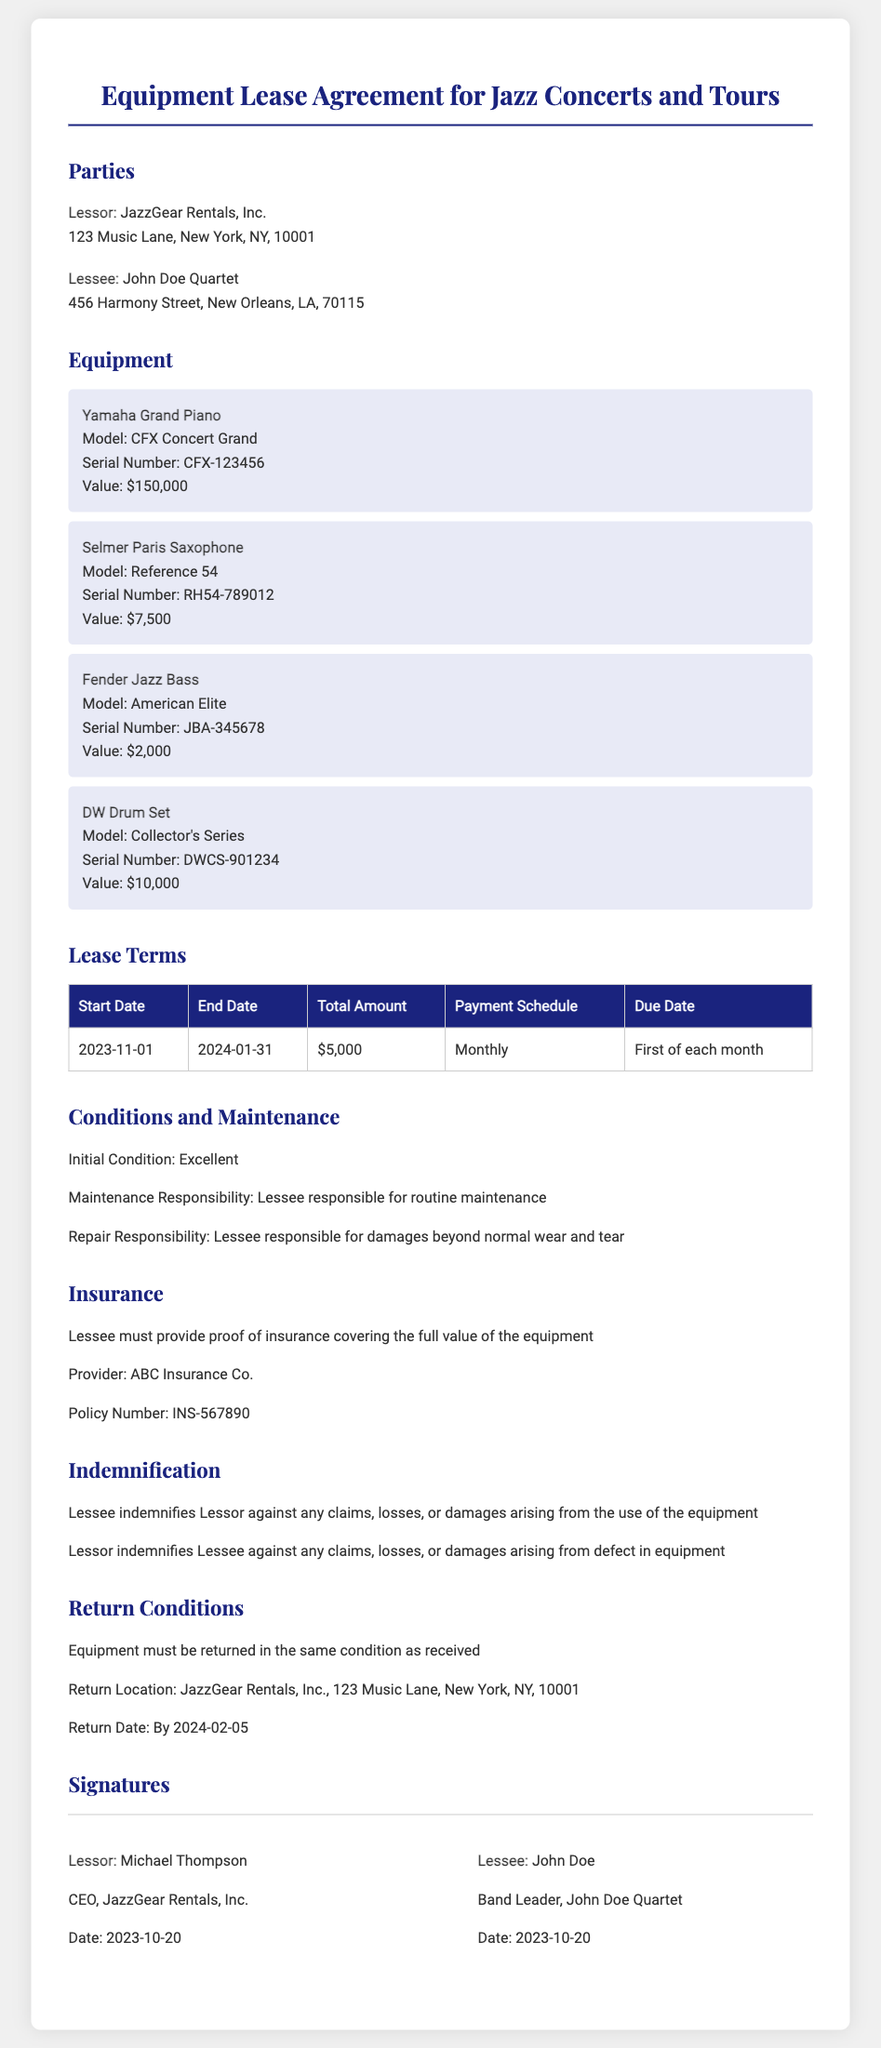What is the name of the Lessor? The Lessor is identified as JazzGear Rentals, Inc. in the document.
Answer: JazzGear Rentals, Inc What is the total amount of the lease? The total amount is mentioned in the lease terms section of the document as $5,000.
Answer: $5,000 Who is responsible for routine maintenance? The document states that the Lessee is responsible for routine maintenance of the equipment.
Answer: Lessee What is the return date for the equipment? The required return date for the equipment is specified in the return conditions section as 2024-02-05.
Answer: 2024-02-05 What type of insurance must the Lessee provide? The document indicates the Lessee must provide proof of insurance covering the full value of the equipment.
Answer: Proof of insurance What is the serial number of the Yamaha Grand Piano? The serial number is listed under the equipment section, specifically for the Yamaha Grand Piano.
Answer: CFX-123456 How long is the lease period? The lease period spans from the start date of November 1, 2023, to the end date of January 31, 2024, which totals three months.
Answer: Three months What is the return location for the equipment? The return location for the equipment is stated as JazzGear Rentals, Inc., 123 Music Lane, New York, NY, 10001.
Answer: JazzGear Rentals, Inc., 123 Music Lane, New York, NY, 10001 Who is the CEO of the Lessor? The document lists the CEO of JazzGear Rentals, Inc. as Michael Thompson.
Answer: Michael Thompson 